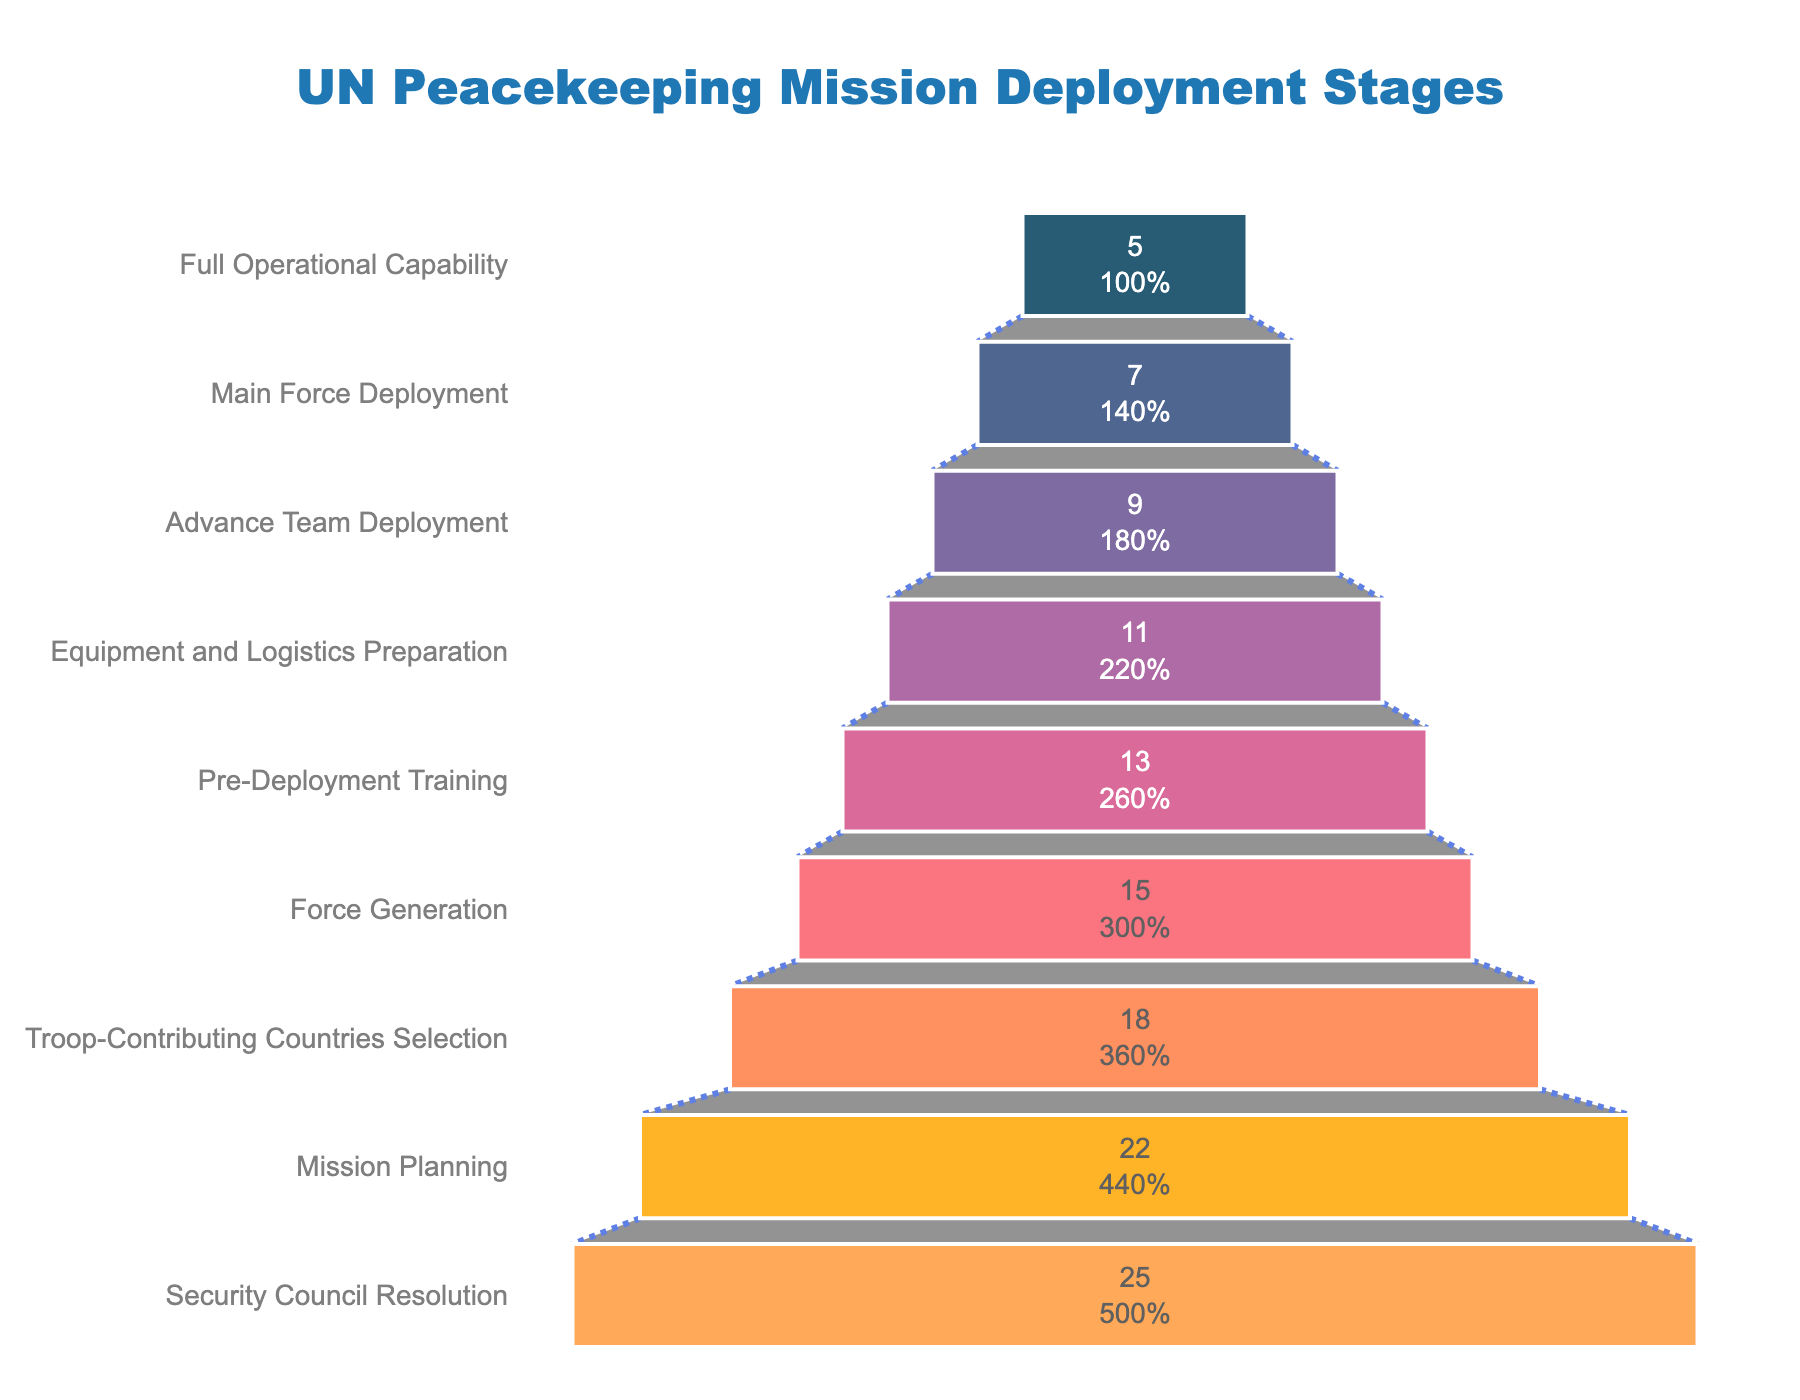How many stages are depicted in the funnel chart? The funnel chart shows a vertical progression with stages listed from top to bottom. Each unique label represents a stage. Counting the stages from the title to the bottom, there are a total of 9 stages.
Answer: 9 What is the title of the funnel chart? The title is displayed prominently at the top of the funnel chart. It provides a clear description of what the chart illustrates, which is "UN Peacekeeping Mission Deployment Stages."
Answer: UN Peacekeeping Mission Deployment Stages Which stage has the highest number of missions? Looking at the values listed next to each stage, the "Security Council Resolution" stage has the largest number listed, which is 25.
Answer: Security Council Resolution What percentage of missions move from the Mission Planning stage to the Troop-Contributing Countries Selection stage? The Mission Planning stage has 22 missions, and the Troop-Contributing Countries Selection stage has 18 missions. To find the percentage that moves on, (18/22) × 100% = 81.82%.
Answer: 81.82% How many stages have fewer than 10 missions? By examining the vertical list, the stages "Advance Team Deployment," "Main Force Deployment," and "Full Operational Capability" each have fewer than 10 missions. Counting these gives a total of 3 stages.
Answer: 3 What is the total number of missions accounted for in the funnel chart? Summing all the numbers of missions from each stage: 25 + 22 + 18 + 15 + 13 + 11 + 9 + 7 + 5 = 125.
Answer: 125 How many more missions are there in the Mission Planning stage compared to the Main Force Deployment stage? The Mission Planning stage has 22 missions, while the Main Force Deployment stage has 7 missions. The difference between them is 22 - 7 = 15.
Answer: 15 Compare the number of missions in Pre-Deployment Training and Force Generation stages. Which one is greater and by how much? Pre-Deployment Training has 13 missions, while Force Generation has 15 missions. Force Generation has more missions, specifically by 15 - 13 = 2 missions.
Answer: Force Generation by 2 List the stages where more than 50% of the missions pass on to the next stage. Calculate the percentage passed from each stage to the next: 
Security Council Resolution to Mission Planning (22/25) = 88%,
Mission Planning to Troop-Contributing Countries Selection (18/22) = 82%,
Troop-Contributing Countries Selection to Force Generation (15/18) = 83%,
Force Generation to Pre-Deployment Training (13/15) = 87%,
Pre-Deployment Training to Equipment and Logistics Preparation (11/13) = 85%,
Equipment and Logistics Preparation to Advance Team Deployment (9/11) = 82%,
Advance Team Deployment to Main Force Deployment (7/9) = 78%,
Main Force Deployment to Full Operational Capability (5/7) = 71%.
All these stages pass more than 50% of missions to the next stage.
Answer: All stages What percentage of missions reach Full Operational Capability from Security Council Resolution through all stages? Start with 25 missions at Security Council Resolution. The number reaching Full Operational Capability is 5. The percentage is (5/25) × 100% = 20%.
Answer: 20% 